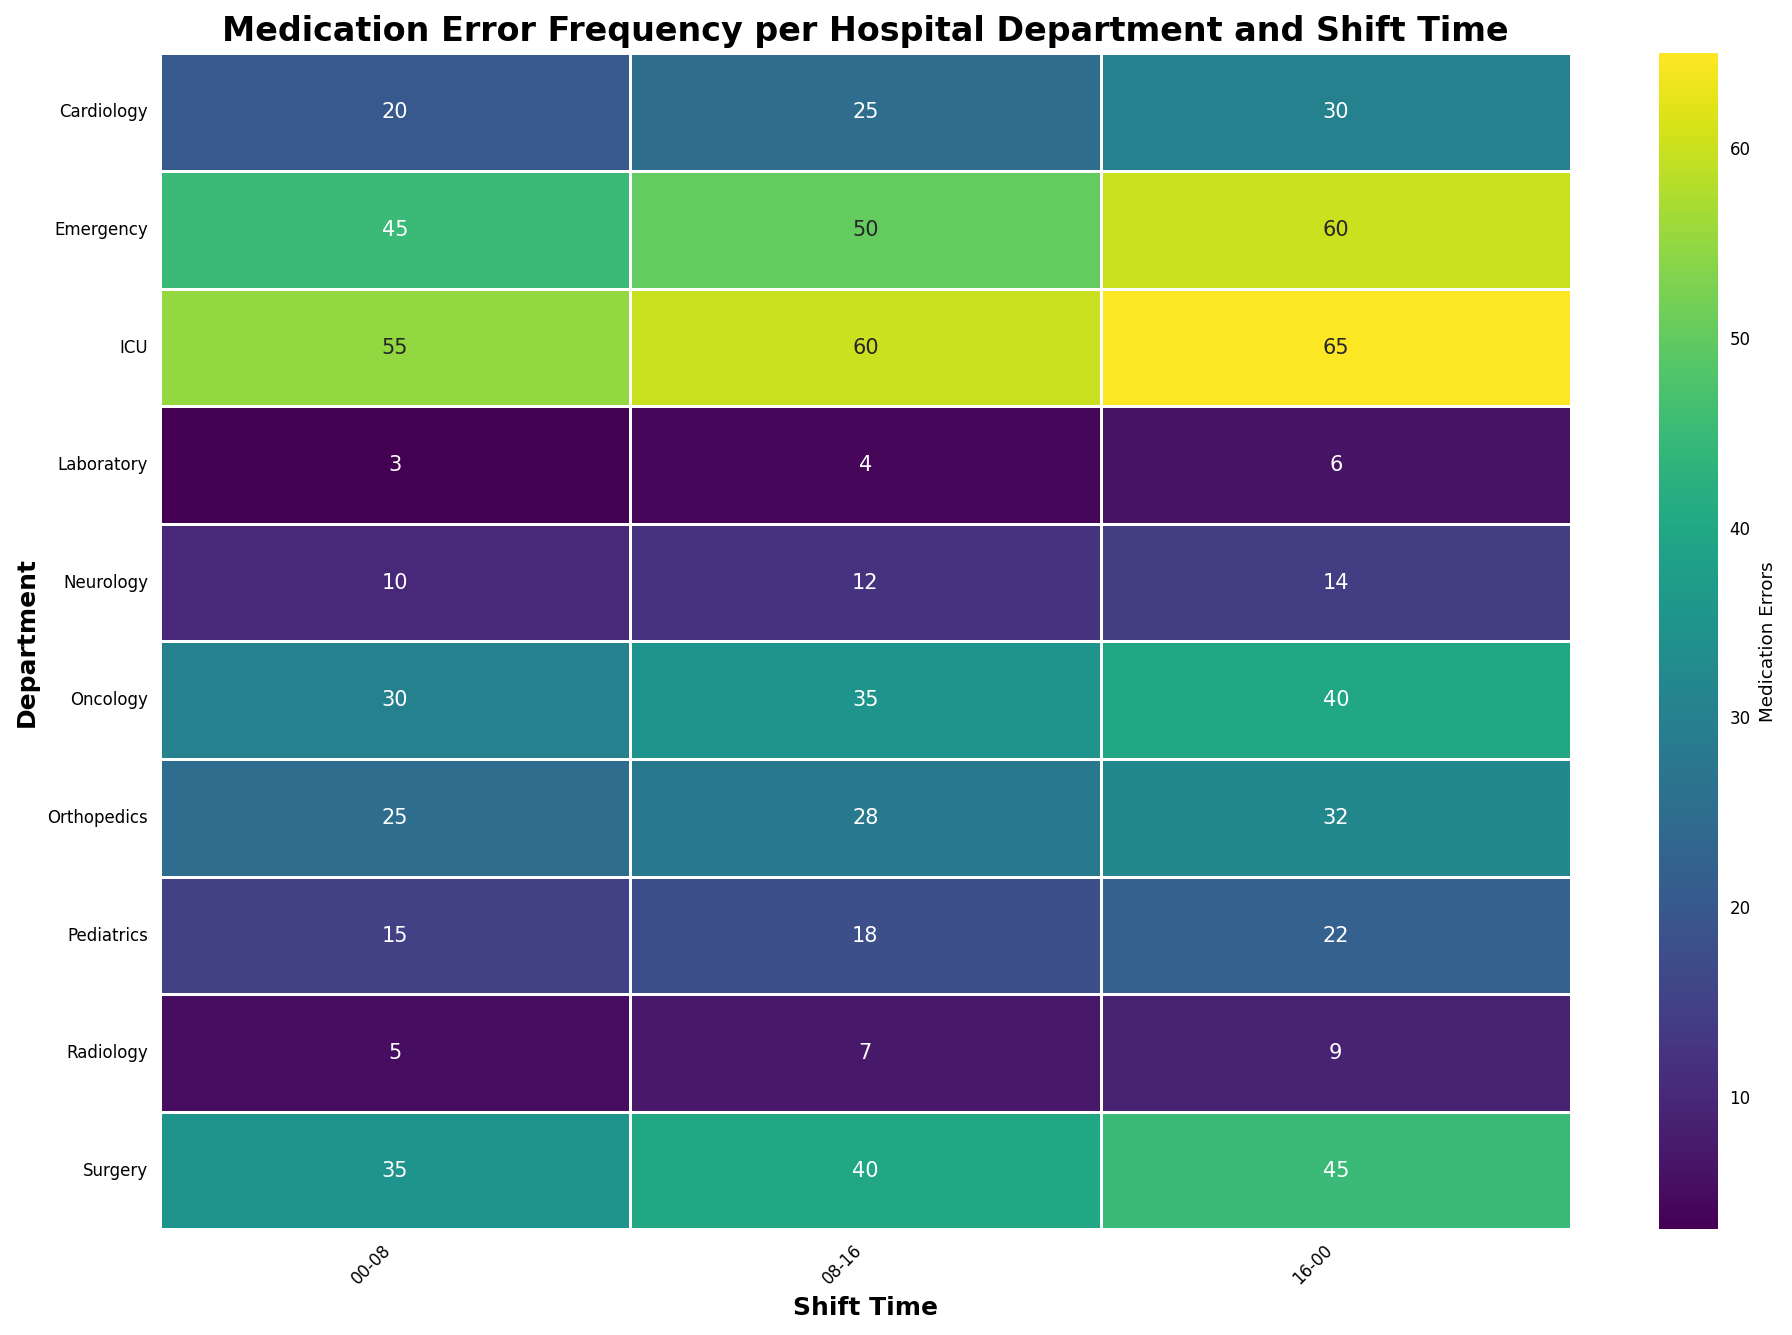What department has the highest number of medication errors during any shift? To find the department with the highest number of medication errors, observe the annotated values in the heatmap. The highest number noted is 65 errors in the ICU during the 16-00 shift.
Answer: ICU How does the number of medication errors in the Emergency department change across different shifts? For the Emergency department, track the values across the three shifts: 45 (00-08), 50 (08-16), and 60 (16-00). The number of errors increases from 45 to 50 to 60.
Answer: Increasing Which department experiences the lowest number of medication errors during the 08-16 shift? Look at the medication errors in each department during the 08-16 shift. The Laboratory has the lowest with 4 errors.
Answer: Laboratory What is the sum of medication errors in the Cardiology department across all shifts? Add the number of errors in Cardiology across the three shifts which are 20 (00-08), 25 (08-16), and 30 (16-00): 20 + 25 + 30 = 75.
Answer: 75 What is the difference in medication errors between the ICU's 16-00 shift and Radiology's 00-08 shift? Subtract the number of errors in Radiology's 00-08 shift from ICU's 16-00 shift: 65 - 5 = 60.
Answer: 60 Compare the medication errors in Pediatrics and Neurology during the 00-08 shift. Which has fewer errors? Observe the number of errors during the 00-08 shift for both departments: Pediatrics has 15 and Neurology has 10. Neurology has fewer errors.
Answer: Neurology What trend is visible in the medication errors in Surgery across the three shifts? Investigate the change in errors across the shifts: Surgery has 35 (00-08), 40 (08-16), and 45 (16-00). The errors show an increasing trend.
Answer: Increasing What is the average number of medication errors for the Orthopedics department across all shifts? Calculate the average by summing the errors across shifts 25 (00-08), 28 (08-16), and 32 (16-00), and then dividing by 3. (25 + 28 + 32) / 3 = 28.33.
Answer: 28.33 Which shift time has the highest medication errors in total across all departments? Sum the errors for all departments across each shift time: 
For 00-08: (45+20+30+15+10+25+35+55+5+3) = 243,
For 08-16: (50+25+35+18+12+28+40+60+7+4) = 279,
For 16-00: (60+30+40+22+14+32+45+65+9+6) = 323.
The shift 16-00 has the highest total errors.
Answer: 16-00 